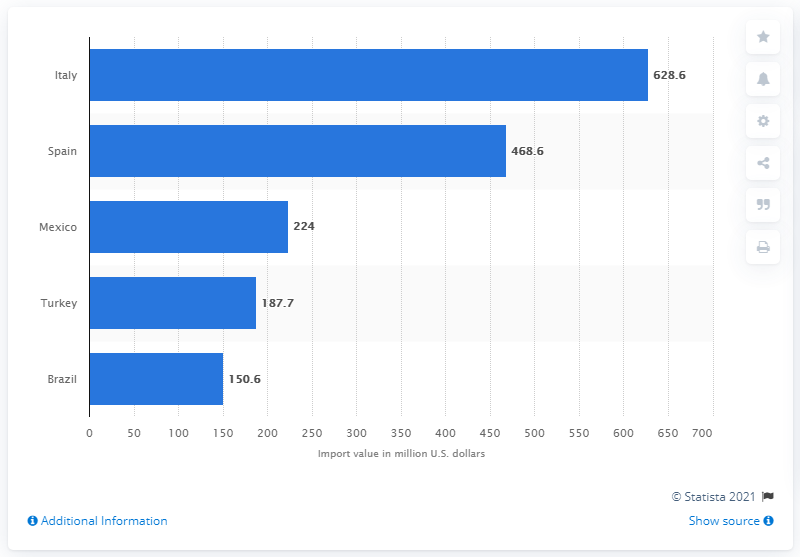Specify some key components in this picture. In 2020, Italy was the leading provider of ceramic tiles imported into the United States, accounting for the greatest value of imports in that year. In 2020, a total of 628.6 million dollars was imported from Italy to the United States. 